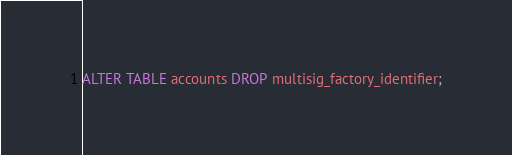<code> <loc_0><loc_0><loc_500><loc_500><_SQL_>ALTER TABLE accounts DROP multisig_factory_identifier;

</code> 